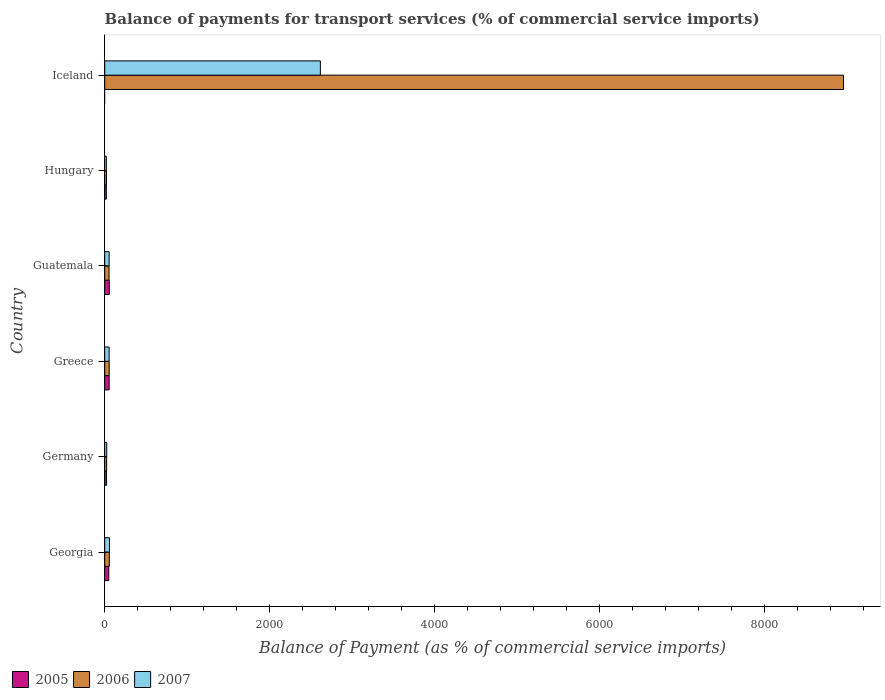How many groups of bars are there?
Provide a short and direct response. 6. Are the number of bars on each tick of the Y-axis equal?
Provide a succinct answer. No. What is the label of the 3rd group of bars from the top?
Provide a succinct answer. Guatemala. What is the balance of payments for transport services in 2006 in Georgia?
Your response must be concise. 56. Across all countries, what is the maximum balance of payments for transport services in 2006?
Your answer should be compact. 8952.73. Across all countries, what is the minimum balance of payments for transport services in 2006?
Give a very brief answer. 21.15. In which country was the balance of payments for transport services in 2005 maximum?
Your response must be concise. Guatemala. What is the total balance of payments for transport services in 2006 in the graph?
Provide a short and direct response. 9159.91. What is the difference between the balance of payments for transport services in 2007 in Greece and that in Guatemala?
Your response must be concise. -0.3. What is the difference between the balance of payments for transport services in 2006 in Germany and the balance of payments for transport services in 2005 in Georgia?
Your response must be concise. -25.61. What is the average balance of payments for transport services in 2005 per country?
Your answer should be very brief. 33.38. What is the difference between the balance of payments for transport services in 2007 and balance of payments for transport services in 2005 in Hungary?
Provide a succinct answer. 0.12. What is the ratio of the balance of payments for transport services in 2007 in Greece to that in Iceland?
Keep it short and to the point. 0.02. Is the balance of payments for transport services in 2005 in Greece less than that in Hungary?
Keep it short and to the point. No. What is the difference between the highest and the second highest balance of payments for transport services in 2005?
Your response must be concise. 1.66. What is the difference between the highest and the lowest balance of payments for transport services in 2007?
Offer a terse response. 2593.2. In how many countries, is the balance of payments for transport services in 2006 greater than the average balance of payments for transport services in 2006 taken over all countries?
Your answer should be compact. 1. Is the sum of the balance of payments for transport services in 2006 in Georgia and Hungary greater than the maximum balance of payments for transport services in 2005 across all countries?
Give a very brief answer. Yes. Is it the case that in every country, the sum of the balance of payments for transport services in 2005 and balance of payments for transport services in 2006 is greater than the balance of payments for transport services in 2007?
Make the answer very short. Yes. How many bars are there?
Offer a terse response. 17. Are the values on the major ticks of X-axis written in scientific E-notation?
Ensure brevity in your answer.  No. Does the graph contain grids?
Give a very brief answer. No. Where does the legend appear in the graph?
Your answer should be compact. Bottom left. What is the title of the graph?
Provide a short and direct response. Balance of payments for transport services (% of commercial service imports). Does "1987" appear as one of the legend labels in the graph?
Give a very brief answer. No. What is the label or title of the X-axis?
Your answer should be compact. Balance of Payment (as % of commercial service imports). What is the Balance of Payment (as % of commercial service imports) of 2005 in Georgia?
Your answer should be very brief. 49.05. What is the Balance of Payment (as % of commercial service imports) in 2006 in Georgia?
Your answer should be very brief. 56. What is the Balance of Payment (as % of commercial service imports) of 2007 in Georgia?
Keep it short and to the point. 58.09. What is the Balance of Payment (as % of commercial service imports) of 2005 in Germany?
Give a very brief answer. 21.91. What is the Balance of Payment (as % of commercial service imports) in 2006 in Germany?
Keep it short and to the point. 23.44. What is the Balance of Payment (as % of commercial service imports) of 2007 in Germany?
Give a very brief answer. 24.6. What is the Balance of Payment (as % of commercial service imports) of 2005 in Greece?
Your answer should be compact. 53.86. What is the Balance of Payment (as % of commercial service imports) of 2006 in Greece?
Offer a very short reply. 54.19. What is the Balance of Payment (as % of commercial service imports) of 2007 in Greece?
Keep it short and to the point. 53.34. What is the Balance of Payment (as % of commercial service imports) in 2005 in Guatemala?
Make the answer very short. 55.52. What is the Balance of Payment (as % of commercial service imports) in 2006 in Guatemala?
Keep it short and to the point. 52.41. What is the Balance of Payment (as % of commercial service imports) of 2007 in Guatemala?
Offer a very short reply. 53.64. What is the Balance of Payment (as % of commercial service imports) of 2005 in Hungary?
Your response must be concise. 19.94. What is the Balance of Payment (as % of commercial service imports) in 2006 in Hungary?
Your answer should be compact. 21.15. What is the Balance of Payment (as % of commercial service imports) in 2007 in Hungary?
Give a very brief answer. 20.06. What is the Balance of Payment (as % of commercial service imports) of 2005 in Iceland?
Make the answer very short. 0. What is the Balance of Payment (as % of commercial service imports) of 2006 in Iceland?
Your answer should be compact. 8952.73. What is the Balance of Payment (as % of commercial service imports) in 2007 in Iceland?
Ensure brevity in your answer.  2613.27. Across all countries, what is the maximum Balance of Payment (as % of commercial service imports) of 2005?
Your answer should be very brief. 55.52. Across all countries, what is the maximum Balance of Payment (as % of commercial service imports) in 2006?
Provide a succinct answer. 8952.73. Across all countries, what is the maximum Balance of Payment (as % of commercial service imports) of 2007?
Make the answer very short. 2613.27. Across all countries, what is the minimum Balance of Payment (as % of commercial service imports) of 2005?
Keep it short and to the point. 0. Across all countries, what is the minimum Balance of Payment (as % of commercial service imports) in 2006?
Give a very brief answer. 21.15. Across all countries, what is the minimum Balance of Payment (as % of commercial service imports) of 2007?
Provide a short and direct response. 20.06. What is the total Balance of Payment (as % of commercial service imports) of 2005 in the graph?
Give a very brief answer. 200.27. What is the total Balance of Payment (as % of commercial service imports) in 2006 in the graph?
Keep it short and to the point. 9159.91. What is the total Balance of Payment (as % of commercial service imports) of 2007 in the graph?
Your answer should be compact. 2823. What is the difference between the Balance of Payment (as % of commercial service imports) in 2005 in Georgia and that in Germany?
Your answer should be compact. 27.15. What is the difference between the Balance of Payment (as % of commercial service imports) of 2006 in Georgia and that in Germany?
Give a very brief answer. 32.56. What is the difference between the Balance of Payment (as % of commercial service imports) of 2007 in Georgia and that in Germany?
Make the answer very short. 33.49. What is the difference between the Balance of Payment (as % of commercial service imports) in 2005 in Georgia and that in Greece?
Offer a very short reply. -4.81. What is the difference between the Balance of Payment (as % of commercial service imports) in 2006 in Georgia and that in Greece?
Offer a terse response. 1.82. What is the difference between the Balance of Payment (as % of commercial service imports) in 2007 in Georgia and that in Greece?
Provide a short and direct response. 4.75. What is the difference between the Balance of Payment (as % of commercial service imports) of 2005 in Georgia and that in Guatemala?
Make the answer very short. -6.46. What is the difference between the Balance of Payment (as % of commercial service imports) of 2006 in Georgia and that in Guatemala?
Your answer should be very brief. 3.59. What is the difference between the Balance of Payment (as % of commercial service imports) in 2007 in Georgia and that in Guatemala?
Your response must be concise. 4.44. What is the difference between the Balance of Payment (as % of commercial service imports) in 2005 in Georgia and that in Hungary?
Offer a very short reply. 29.11. What is the difference between the Balance of Payment (as % of commercial service imports) of 2006 in Georgia and that in Hungary?
Your answer should be compact. 34.85. What is the difference between the Balance of Payment (as % of commercial service imports) in 2007 in Georgia and that in Hungary?
Ensure brevity in your answer.  38.02. What is the difference between the Balance of Payment (as % of commercial service imports) in 2006 in Georgia and that in Iceland?
Offer a terse response. -8896.73. What is the difference between the Balance of Payment (as % of commercial service imports) in 2007 in Georgia and that in Iceland?
Offer a very short reply. -2555.18. What is the difference between the Balance of Payment (as % of commercial service imports) in 2005 in Germany and that in Greece?
Keep it short and to the point. -31.95. What is the difference between the Balance of Payment (as % of commercial service imports) in 2006 in Germany and that in Greece?
Offer a very short reply. -30.75. What is the difference between the Balance of Payment (as % of commercial service imports) in 2007 in Germany and that in Greece?
Ensure brevity in your answer.  -28.74. What is the difference between the Balance of Payment (as % of commercial service imports) in 2005 in Germany and that in Guatemala?
Your answer should be very brief. -33.61. What is the difference between the Balance of Payment (as % of commercial service imports) of 2006 in Germany and that in Guatemala?
Ensure brevity in your answer.  -28.97. What is the difference between the Balance of Payment (as % of commercial service imports) in 2007 in Germany and that in Guatemala?
Make the answer very short. -29.05. What is the difference between the Balance of Payment (as % of commercial service imports) in 2005 in Germany and that in Hungary?
Offer a very short reply. 1.97. What is the difference between the Balance of Payment (as % of commercial service imports) of 2006 in Germany and that in Hungary?
Ensure brevity in your answer.  2.29. What is the difference between the Balance of Payment (as % of commercial service imports) in 2007 in Germany and that in Hungary?
Offer a terse response. 4.53. What is the difference between the Balance of Payment (as % of commercial service imports) in 2006 in Germany and that in Iceland?
Give a very brief answer. -8929.29. What is the difference between the Balance of Payment (as % of commercial service imports) of 2007 in Germany and that in Iceland?
Offer a terse response. -2588.67. What is the difference between the Balance of Payment (as % of commercial service imports) in 2005 in Greece and that in Guatemala?
Your response must be concise. -1.66. What is the difference between the Balance of Payment (as % of commercial service imports) in 2006 in Greece and that in Guatemala?
Make the answer very short. 1.78. What is the difference between the Balance of Payment (as % of commercial service imports) in 2007 in Greece and that in Guatemala?
Provide a succinct answer. -0.3. What is the difference between the Balance of Payment (as % of commercial service imports) in 2005 in Greece and that in Hungary?
Offer a very short reply. 33.92. What is the difference between the Balance of Payment (as % of commercial service imports) of 2006 in Greece and that in Hungary?
Provide a short and direct response. 33.04. What is the difference between the Balance of Payment (as % of commercial service imports) of 2007 in Greece and that in Hungary?
Your response must be concise. 33.28. What is the difference between the Balance of Payment (as % of commercial service imports) of 2006 in Greece and that in Iceland?
Ensure brevity in your answer.  -8898.54. What is the difference between the Balance of Payment (as % of commercial service imports) of 2007 in Greece and that in Iceland?
Give a very brief answer. -2559.93. What is the difference between the Balance of Payment (as % of commercial service imports) of 2005 in Guatemala and that in Hungary?
Make the answer very short. 35.58. What is the difference between the Balance of Payment (as % of commercial service imports) in 2006 in Guatemala and that in Hungary?
Make the answer very short. 31.26. What is the difference between the Balance of Payment (as % of commercial service imports) in 2007 in Guatemala and that in Hungary?
Provide a succinct answer. 33.58. What is the difference between the Balance of Payment (as % of commercial service imports) in 2006 in Guatemala and that in Iceland?
Make the answer very short. -8900.32. What is the difference between the Balance of Payment (as % of commercial service imports) in 2007 in Guatemala and that in Iceland?
Offer a very short reply. -2559.62. What is the difference between the Balance of Payment (as % of commercial service imports) in 2006 in Hungary and that in Iceland?
Provide a short and direct response. -8931.58. What is the difference between the Balance of Payment (as % of commercial service imports) of 2007 in Hungary and that in Iceland?
Make the answer very short. -2593.2. What is the difference between the Balance of Payment (as % of commercial service imports) of 2005 in Georgia and the Balance of Payment (as % of commercial service imports) of 2006 in Germany?
Provide a short and direct response. 25.61. What is the difference between the Balance of Payment (as % of commercial service imports) of 2005 in Georgia and the Balance of Payment (as % of commercial service imports) of 2007 in Germany?
Your response must be concise. 24.46. What is the difference between the Balance of Payment (as % of commercial service imports) of 2006 in Georgia and the Balance of Payment (as % of commercial service imports) of 2007 in Germany?
Give a very brief answer. 31.4. What is the difference between the Balance of Payment (as % of commercial service imports) in 2005 in Georgia and the Balance of Payment (as % of commercial service imports) in 2006 in Greece?
Give a very brief answer. -5.13. What is the difference between the Balance of Payment (as % of commercial service imports) of 2005 in Georgia and the Balance of Payment (as % of commercial service imports) of 2007 in Greece?
Your answer should be very brief. -4.29. What is the difference between the Balance of Payment (as % of commercial service imports) of 2006 in Georgia and the Balance of Payment (as % of commercial service imports) of 2007 in Greece?
Make the answer very short. 2.66. What is the difference between the Balance of Payment (as % of commercial service imports) in 2005 in Georgia and the Balance of Payment (as % of commercial service imports) in 2006 in Guatemala?
Offer a very short reply. -3.36. What is the difference between the Balance of Payment (as % of commercial service imports) in 2005 in Georgia and the Balance of Payment (as % of commercial service imports) in 2007 in Guatemala?
Ensure brevity in your answer.  -4.59. What is the difference between the Balance of Payment (as % of commercial service imports) in 2006 in Georgia and the Balance of Payment (as % of commercial service imports) in 2007 in Guatemala?
Ensure brevity in your answer.  2.36. What is the difference between the Balance of Payment (as % of commercial service imports) in 2005 in Georgia and the Balance of Payment (as % of commercial service imports) in 2006 in Hungary?
Ensure brevity in your answer.  27.91. What is the difference between the Balance of Payment (as % of commercial service imports) of 2005 in Georgia and the Balance of Payment (as % of commercial service imports) of 2007 in Hungary?
Provide a short and direct response. 28.99. What is the difference between the Balance of Payment (as % of commercial service imports) in 2006 in Georgia and the Balance of Payment (as % of commercial service imports) in 2007 in Hungary?
Give a very brief answer. 35.94. What is the difference between the Balance of Payment (as % of commercial service imports) of 2005 in Georgia and the Balance of Payment (as % of commercial service imports) of 2006 in Iceland?
Offer a very short reply. -8903.68. What is the difference between the Balance of Payment (as % of commercial service imports) in 2005 in Georgia and the Balance of Payment (as % of commercial service imports) in 2007 in Iceland?
Offer a very short reply. -2564.22. What is the difference between the Balance of Payment (as % of commercial service imports) in 2006 in Georgia and the Balance of Payment (as % of commercial service imports) in 2007 in Iceland?
Your response must be concise. -2557.27. What is the difference between the Balance of Payment (as % of commercial service imports) of 2005 in Germany and the Balance of Payment (as % of commercial service imports) of 2006 in Greece?
Provide a short and direct response. -32.28. What is the difference between the Balance of Payment (as % of commercial service imports) of 2005 in Germany and the Balance of Payment (as % of commercial service imports) of 2007 in Greece?
Your answer should be compact. -31.43. What is the difference between the Balance of Payment (as % of commercial service imports) in 2006 in Germany and the Balance of Payment (as % of commercial service imports) in 2007 in Greece?
Offer a terse response. -29.9. What is the difference between the Balance of Payment (as % of commercial service imports) in 2005 in Germany and the Balance of Payment (as % of commercial service imports) in 2006 in Guatemala?
Offer a very short reply. -30.5. What is the difference between the Balance of Payment (as % of commercial service imports) in 2005 in Germany and the Balance of Payment (as % of commercial service imports) in 2007 in Guatemala?
Keep it short and to the point. -31.74. What is the difference between the Balance of Payment (as % of commercial service imports) in 2006 in Germany and the Balance of Payment (as % of commercial service imports) in 2007 in Guatemala?
Your answer should be compact. -30.21. What is the difference between the Balance of Payment (as % of commercial service imports) in 2005 in Germany and the Balance of Payment (as % of commercial service imports) in 2006 in Hungary?
Give a very brief answer. 0.76. What is the difference between the Balance of Payment (as % of commercial service imports) in 2005 in Germany and the Balance of Payment (as % of commercial service imports) in 2007 in Hungary?
Your answer should be very brief. 1.84. What is the difference between the Balance of Payment (as % of commercial service imports) in 2006 in Germany and the Balance of Payment (as % of commercial service imports) in 2007 in Hungary?
Offer a very short reply. 3.37. What is the difference between the Balance of Payment (as % of commercial service imports) in 2005 in Germany and the Balance of Payment (as % of commercial service imports) in 2006 in Iceland?
Provide a succinct answer. -8930.82. What is the difference between the Balance of Payment (as % of commercial service imports) of 2005 in Germany and the Balance of Payment (as % of commercial service imports) of 2007 in Iceland?
Provide a short and direct response. -2591.36. What is the difference between the Balance of Payment (as % of commercial service imports) of 2006 in Germany and the Balance of Payment (as % of commercial service imports) of 2007 in Iceland?
Make the answer very short. -2589.83. What is the difference between the Balance of Payment (as % of commercial service imports) of 2005 in Greece and the Balance of Payment (as % of commercial service imports) of 2006 in Guatemala?
Give a very brief answer. 1.45. What is the difference between the Balance of Payment (as % of commercial service imports) of 2005 in Greece and the Balance of Payment (as % of commercial service imports) of 2007 in Guatemala?
Provide a succinct answer. 0.22. What is the difference between the Balance of Payment (as % of commercial service imports) in 2006 in Greece and the Balance of Payment (as % of commercial service imports) in 2007 in Guatemala?
Your response must be concise. 0.54. What is the difference between the Balance of Payment (as % of commercial service imports) in 2005 in Greece and the Balance of Payment (as % of commercial service imports) in 2006 in Hungary?
Give a very brief answer. 32.71. What is the difference between the Balance of Payment (as % of commercial service imports) of 2005 in Greece and the Balance of Payment (as % of commercial service imports) of 2007 in Hungary?
Your answer should be compact. 33.8. What is the difference between the Balance of Payment (as % of commercial service imports) of 2006 in Greece and the Balance of Payment (as % of commercial service imports) of 2007 in Hungary?
Your response must be concise. 34.12. What is the difference between the Balance of Payment (as % of commercial service imports) of 2005 in Greece and the Balance of Payment (as % of commercial service imports) of 2006 in Iceland?
Your response must be concise. -8898.87. What is the difference between the Balance of Payment (as % of commercial service imports) in 2005 in Greece and the Balance of Payment (as % of commercial service imports) in 2007 in Iceland?
Your answer should be compact. -2559.41. What is the difference between the Balance of Payment (as % of commercial service imports) in 2006 in Greece and the Balance of Payment (as % of commercial service imports) in 2007 in Iceland?
Provide a short and direct response. -2559.08. What is the difference between the Balance of Payment (as % of commercial service imports) of 2005 in Guatemala and the Balance of Payment (as % of commercial service imports) of 2006 in Hungary?
Ensure brevity in your answer.  34.37. What is the difference between the Balance of Payment (as % of commercial service imports) in 2005 in Guatemala and the Balance of Payment (as % of commercial service imports) in 2007 in Hungary?
Offer a terse response. 35.45. What is the difference between the Balance of Payment (as % of commercial service imports) in 2006 in Guatemala and the Balance of Payment (as % of commercial service imports) in 2007 in Hungary?
Keep it short and to the point. 32.35. What is the difference between the Balance of Payment (as % of commercial service imports) in 2005 in Guatemala and the Balance of Payment (as % of commercial service imports) in 2006 in Iceland?
Give a very brief answer. -8897.21. What is the difference between the Balance of Payment (as % of commercial service imports) in 2005 in Guatemala and the Balance of Payment (as % of commercial service imports) in 2007 in Iceland?
Ensure brevity in your answer.  -2557.75. What is the difference between the Balance of Payment (as % of commercial service imports) of 2006 in Guatemala and the Balance of Payment (as % of commercial service imports) of 2007 in Iceland?
Keep it short and to the point. -2560.86. What is the difference between the Balance of Payment (as % of commercial service imports) of 2005 in Hungary and the Balance of Payment (as % of commercial service imports) of 2006 in Iceland?
Ensure brevity in your answer.  -8932.79. What is the difference between the Balance of Payment (as % of commercial service imports) of 2005 in Hungary and the Balance of Payment (as % of commercial service imports) of 2007 in Iceland?
Provide a short and direct response. -2593.33. What is the difference between the Balance of Payment (as % of commercial service imports) of 2006 in Hungary and the Balance of Payment (as % of commercial service imports) of 2007 in Iceland?
Give a very brief answer. -2592.12. What is the average Balance of Payment (as % of commercial service imports) of 2005 per country?
Ensure brevity in your answer.  33.38. What is the average Balance of Payment (as % of commercial service imports) of 2006 per country?
Your answer should be very brief. 1526.65. What is the average Balance of Payment (as % of commercial service imports) in 2007 per country?
Offer a very short reply. 470.5. What is the difference between the Balance of Payment (as % of commercial service imports) in 2005 and Balance of Payment (as % of commercial service imports) in 2006 in Georgia?
Keep it short and to the point. -6.95. What is the difference between the Balance of Payment (as % of commercial service imports) in 2005 and Balance of Payment (as % of commercial service imports) in 2007 in Georgia?
Make the answer very short. -9.04. What is the difference between the Balance of Payment (as % of commercial service imports) in 2006 and Balance of Payment (as % of commercial service imports) in 2007 in Georgia?
Keep it short and to the point. -2.09. What is the difference between the Balance of Payment (as % of commercial service imports) of 2005 and Balance of Payment (as % of commercial service imports) of 2006 in Germany?
Make the answer very short. -1.53. What is the difference between the Balance of Payment (as % of commercial service imports) of 2005 and Balance of Payment (as % of commercial service imports) of 2007 in Germany?
Ensure brevity in your answer.  -2.69. What is the difference between the Balance of Payment (as % of commercial service imports) in 2006 and Balance of Payment (as % of commercial service imports) in 2007 in Germany?
Your response must be concise. -1.16. What is the difference between the Balance of Payment (as % of commercial service imports) in 2005 and Balance of Payment (as % of commercial service imports) in 2006 in Greece?
Give a very brief answer. -0.33. What is the difference between the Balance of Payment (as % of commercial service imports) of 2005 and Balance of Payment (as % of commercial service imports) of 2007 in Greece?
Provide a succinct answer. 0.52. What is the difference between the Balance of Payment (as % of commercial service imports) of 2006 and Balance of Payment (as % of commercial service imports) of 2007 in Greece?
Keep it short and to the point. 0.85. What is the difference between the Balance of Payment (as % of commercial service imports) in 2005 and Balance of Payment (as % of commercial service imports) in 2006 in Guatemala?
Give a very brief answer. 3.11. What is the difference between the Balance of Payment (as % of commercial service imports) of 2005 and Balance of Payment (as % of commercial service imports) of 2007 in Guatemala?
Provide a short and direct response. 1.87. What is the difference between the Balance of Payment (as % of commercial service imports) of 2006 and Balance of Payment (as % of commercial service imports) of 2007 in Guatemala?
Your response must be concise. -1.24. What is the difference between the Balance of Payment (as % of commercial service imports) in 2005 and Balance of Payment (as % of commercial service imports) in 2006 in Hungary?
Your response must be concise. -1.21. What is the difference between the Balance of Payment (as % of commercial service imports) of 2005 and Balance of Payment (as % of commercial service imports) of 2007 in Hungary?
Provide a succinct answer. -0.12. What is the difference between the Balance of Payment (as % of commercial service imports) in 2006 and Balance of Payment (as % of commercial service imports) in 2007 in Hungary?
Your answer should be very brief. 1.08. What is the difference between the Balance of Payment (as % of commercial service imports) in 2006 and Balance of Payment (as % of commercial service imports) in 2007 in Iceland?
Your answer should be compact. 6339.46. What is the ratio of the Balance of Payment (as % of commercial service imports) of 2005 in Georgia to that in Germany?
Make the answer very short. 2.24. What is the ratio of the Balance of Payment (as % of commercial service imports) in 2006 in Georgia to that in Germany?
Your response must be concise. 2.39. What is the ratio of the Balance of Payment (as % of commercial service imports) of 2007 in Georgia to that in Germany?
Your answer should be compact. 2.36. What is the ratio of the Balance of Payment (as % of commercial service imports) of 2005 in Georgia to that in Greece?
Give a very brief answer. 0.91. What is the ratio of the Balance of Payment (as % of commercial service imports) in 2006 in Georgia to that in Greece?
Your answer should be very brief. 1.03. What is the ratio of the Balance of Payment (as % of commercial service imports) of 2007 in Georgia to that in Greece?
Offer a terse response. 1.09. What is the ratio of the Balance of Payment (as % of commercial service imports) in 2005 in Georgia to that in Guatemala?
Offer a terse response. 0.88. What is the ratio of the Balance of Payment (as % of commercial service imports) of 2006 in Georgia to that in Guatemala?
Make the answer very short. 1.07. What is the ratio of the Balance of Payment (as % of commercial service imports) of 2007 in Georgia to that in Guatemala?
Your response must be concise. 1.08. What is the ratio of the Balance of Payment (as % of commercial service imports) in 2005 in Georgia to that in Hungary?
Ensure brevity in your answer.  2.46. What is the ratio of the Balance of Payment (as % of commercial service imports) in 2006 in Georgia to that in Hungary?
Your response must be concise. 2.65. What is the ratio of the Balance of Payment (as % of commercial service imports) of 2007 in Georgia to that in Hungary?
Provide a succinct answer. 2.9. What is the ratio of the Balance of Payment (as % of commercial service imports) in 2006 in Georgia to that in Iceland?
Give a very brief answer. 0.01. What is the ratio of the Balance of Payment (as % of commercial service imports) of 2007 in Georgia to that in Iceland?
Keep it short and to the point. 0.02. What is the ratio of the Balance of Payment (as % of commercial service imports) of 2005 in Germany to that in Greece?
Keep it short and to the point. 0.41. What is the ratio of the Balance of Payment (as % of commercial service imports) in 2006 in Germany to that in Greece?
Provide a succinct answer. 0.43. What is the ratio of the Balance of Payment (as % of commercial service imports) of 2007 in Germany to that in Greece?
Make the answer very short. 0.46. What is the ratio of the Balance of Payment (as % of commercial service imports) in 2005 in Germany to that in Guatemala?
Provide a succinct answer. 0.39. What is the ratio of the Balance of Payment (as % of commercial service imports) of 2006 in Germany to that in Guatemala?
Provide a succinct answer. 0.45. What is the ratio of the Balance of Payment (as % of commercial service imports) of 2007 in Germany to that in Guatemala?
Make the answer very short. 0.46. What is the ratio of the Balance of Payment (as % of commercial service imports) in 2005 in Germany to that in Hungary?
Your response must be concise. 1.1. What is the ratio of the Balance of Payment (as % of commercial service imports) of 2006 in Germany to that in Hungary?
Your response must be concise. 1.11. What is the ratio of the Balance of Payment (as % of commercial service imports) of 2007 in Germany to that in Hungary?
Make the answer very short. 1.23. What is the ratio of the Balance of Payment (as % of commercial service imports) of 2006 in Germany to that in Iceland?
Offer a terse response. 0. What is the ratio of the Balance of Payment (as % of commercial service imports) of 2007 in Germany to that in Iceland?
Keep it short and to the point. 0.01. What is the ratio of the Balance of Payment (as % of commercial service imports) of 2005 in Greece to that in Guatemala?
Your answer should be compact. 0.97. What is the ratio of the Balance of Payment (as % of commercial service imports) of 2006 in Greece to that in Guatemala?
Your response must be concise. 1.03. What is the ratio of the Balance of Payment (as % of commercial service imports) in 2007 in Greece to that in Guatemala?
Keep it short and to the point. 0.99. What is the ratio of the Balance of Payment (as % of commercial service imports) in 2005 in Greece to that in Hungary?
Offer a terse response. 2.7. What is the ratio of the Balance of Payment (as % of commercial service imports) of 2006 in Greece to that in Hungary?
Provide a succinct answer. 2.56. What is the ratio of the Balance of Payment (as % of commercial service imports) in 2007 in Greece to that in Hungary?
Your answer should be very brief. 2.66. What is the ratio of the Balance of Payment (as % of commercial service imports) of 2006 in Greece to that in Iceland?
Your answer should be compact. 0.01. What is the ratio of the Balance of Payment (as % of commercial service imports) of 2007 in Greece to that in Iceland?
Your response must be concise. 0.02. What is the ratio of the Balance of Payment (as % of commercial service imports) of 2005 in Guatemala to that in Hungary?
Make the answer very short. 2.78. What is the ratio of the Balance of Payment (as % of commercial service imports) of 2006 in Guatemala to that in Hungary?
Keep it short and to the point. 2.48. What is the ratio of the Balance of Payment (as % of commercial service imports) of 2007 in Guatemala to that in Hungary?
Your response must be concise. 2.67. What is the ratio of the Balance of Payment (as % of commercial service imports) of 2006 in Guatemala to that in Iceland?
Offer a very short reply. 0.01. What is the ratio of the Balance of Payment (as % of commercial service imports) in 2007 in Guatemala to that in Iceland?
Your answer should be compact. 0.02. What is the ratio of the Balance of Payment (as % of commercial service imports) of 2006 in Hungary to that in Iceland?
Provide a short and direct response. 0. What is the ratio of the Balance of Payment (as % of commercial service imports) of 2007 in Hungary to that in Iceland?
Make the answer very short. 0.01. What is the difference between the highest and the second highest Balance of Payment (as % of commercial service imports) of 2005?
Your response must be concise. 1.66. What is the difference between the highest and the second highest Balance of Payment (as % of commercial service imports) of 2006?
Your answer should be very brief. 8896.73. What is the difference between the highest and the second highest Balance of Payment (as % of commercial service imports) of 2007?
Your answer should be very brief. 2555.18. What is the difference between the highest and the lowest Balance of Payment (as % of commercial service imports) in 2005?
Provide a succinct answer. 55.52. What is the difference between the highest and the lowest Balance of Payment (as % of commercial service imports) in 2006?
Your response must be concise. 8931.58. What is the difference between the highest and the lowest Balance of Payment (as % of commercial service imports) of 2007?
Your answer should be compact. 2593.2. 